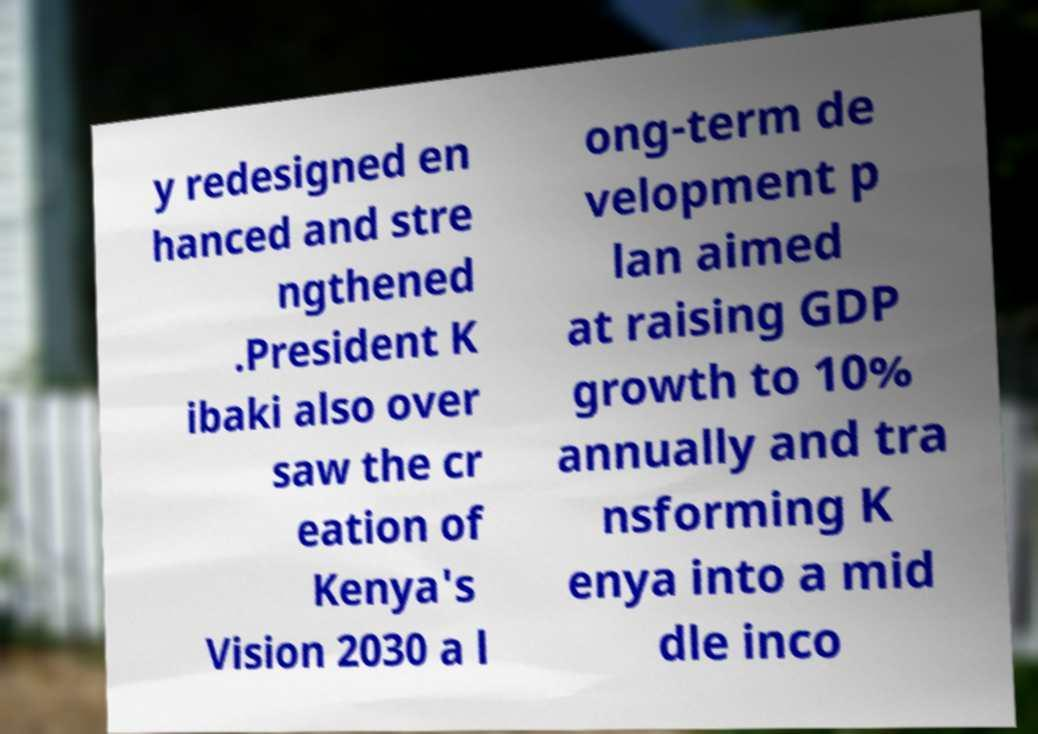Could you assist in decoding the text presented in this image and type it out clearly? y redesigned en hanced and stre ngthened .President K ibaki also over saw the cr eation of Kenya's Vision 2030 a l ong-term de velopment p lan aimed at raising GDP growth to 10% annually and tra nsforming K enya into a mid dle inco 